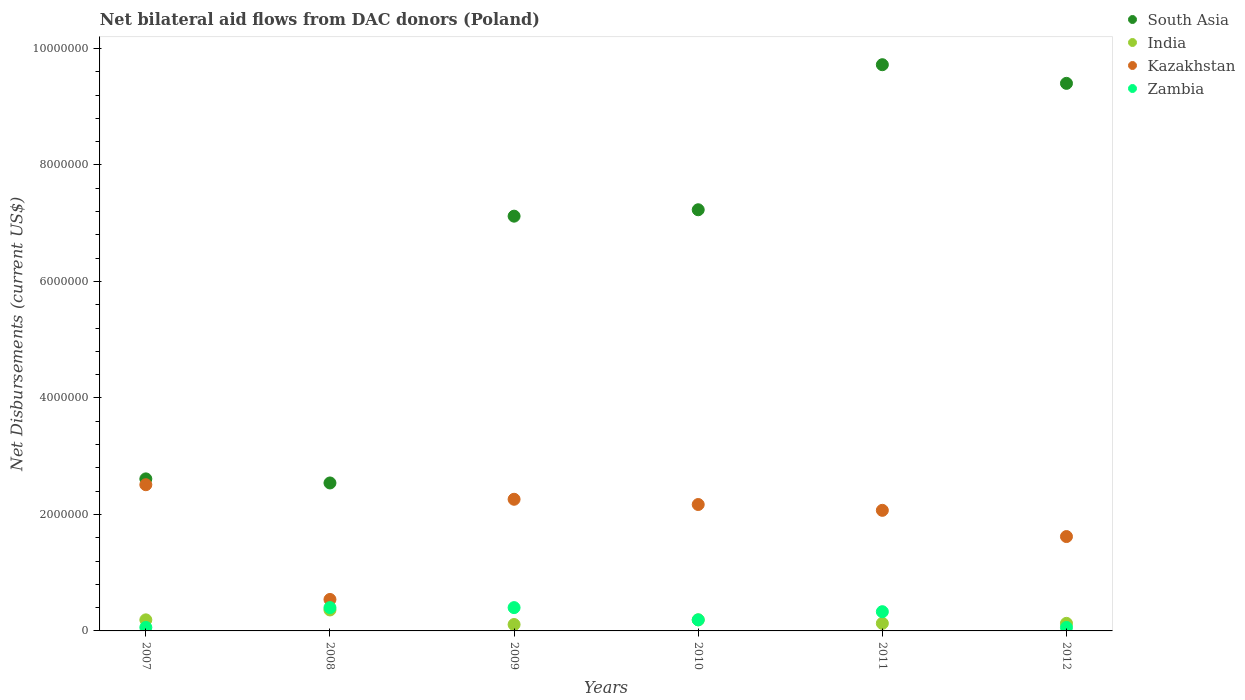How many different coloured dotlines are there?
Ensure brevity in your answer.  4. Is the number of dotlines equal to the number of legend labels?
Your answer should be compact. Yes. What is the net bilateral aid flows in Zambia in 2011?
Make the answer very short. 3.30e+05. Across all years, what is the maximum net bilateral aid flows in South Asia?
Provide a succinct answer. 9.72e+06. Across all years, what is the minimum net bilateral aid flows in Zambia?
Keep it short and to the point. 6.00e+04. In which year was the net bilateral aid flows in Zambia maximum?
Your response must be concise. 2008. In which year was the net bilateral aid flows in Zambia minimum?
Provide a succinct answer. 2007. What is the total net bilateral aid flows in South Asia in the graph?
Your response must be concise. 3.86e+07. What is the difference between the net bilateral aid flows in India in 2007 and that in 2012?
Provide a succinct answer. 6.00e+04. What is the difference between the net bilateral aid flows in Zambia in 2007 and the net bilateral aid flows in South Asia in 2010?
Ensure brevity in your answer.  -7.17e+06. What is the average net bilateral aid flows in South Asia per year?
Give a very brief answer. 6.44e+06. In the year 2012, what is the difference between the net bilateral aid flows in South Asia and net bilateral aid flows in Zambia?
Make the answer very short. 9.34e+06. In how many years, is the net bilateral aid flows in Zambia greater than 6400000 US$?
Keep it short and to the point. 0. What is the ratio of the net bilateral aid flows in India in 2007 to that in 2009?
Give a very brief answer. 1.73. Is the difference between the net bilateral aid flows in South Asia in 2007 and 2012 greater than the difference between the net bilateral aid flows in Zambia in 2007 and 2012?
Ensure brevity in your answer.  No. What is the difference between the highest and the lowest net bilateral aid flows in Zambia?
Your response must be concise. 3.40e+05. Is the sum of the net bilateral aid flows in Kazakhstan in 2010 and 2012 greater than the maximum net bilateral aid flows in India across all years?
Offer a very short reply. Yes. Is it the case that in every year, the sum of the net bilateral aid flows in Kazakhstan and net bilateral aid flows in India  is greater than the net bilateral aid flows in Zambia?
Ensure brevity in your answer.  Yes. Is the net bilateral aid flows in Zambia strictly greater than the net bilateral aid flows in South Asia over the years?
Ensure brevity in your answer.  No. Is the net bilateral aid flows in Kazakhstan strictly less than the net bilateral aid flows in South Asia over the years?
Provide a short and direct response. Yes. How many dotlines are there?
Offer a very short reply. 4. How many years are there in the graph?
Provide a succinct answer. 6. What is the difference between two consecutive major ticks on the Y-axis?
Provide a short and direct response. 2.00e+06. How many legend labels are there?
Your response must be concise. 4. How are the legend labels stacked?
Your response must be concise. Vertical. What is the title of the graph?
Provide a short and direct response. Net bilateral aid flows from DAC donors (Poland). Does "Syrian Arab Republic" appear as one of the legend labels in the graph?
Keep it short and to the point. No. What is the label or title of the X-axis?
Offer a terse response. Years. What is the label or title of the Y-axis?
Your answer should be compact. Net Disbursements (current US$). What is the Net Disbursements (current US$) of South Asia in 2007?
Ensure brevity in your answer.  2.61e+06. What is the Net Disbursements (current US$) in Kazakhstan in 2007?
Your response must be concise. 2.51e+06. What is the Net Disbursements (current US$) in Zambia in 2007?
Offer a terse response. 6.00e+04. What is the Net Disbursements (current US$) in South Asia in 2008?
Ensure brevity in your answer.  2.54e+06. What is the Net Disbursements (current US$) in India in 2008?
Offer a terse response. 3.60e+05. What is the Net Disbursements (current US$) of Kazakhstan in 2008?
Provide a short and direct response. 5.40e+05. What is the Net Disbursements (current US$) of South Asia in 2009?
Your response must be concise. 7.12e+06. What is the Net Disbursements (current US$) of India in 2009?
Your response must be concise. 1.10e+05. What is the Net Disbursements (current US$) of Kazakhstan in 2009?
Keep it short and to the point. 2.26e+06. What is the Net Disbursements (current US$) of South Asia in 2010?
Your answer should be compact. 7.23e+06. What is the Net Disbursements (current US$) of Kazakhstan in 2010?
Provide a short and direct response. 2.17e+06. What is the Net Disbursements (current US$) in Zambia in 2010?
Provide a short and direct response. 1.90e+05. What is the Net Disbursements (current US$) of South Asia in 2011?
Offer a very short reply. 9.72e+06. What is the Net Disbursements (current US$) in India in 2011?
Your answer should be compact. 1.30e+05. What is the Net Disbursements (current US$) in Kazakhstan in 2011?
Provide a short and direct response. 2.07e+06. What is the Net Disbursements (current US$) in Zambia in 2011?
Provide a short and direct response. 3.30e+05. What is the Net Disbursements (current US$) in South Asia in 2012?
Offer a very short reply. 9.40e+06. What is the Net Disbursements (current US$) of India in 2012?
Offer a terse response. 1.30e+05. What is the Net Disbursements (current US$) in Kazakhstan in 2012?
Keep it short and to the point. 1.62e+06. What is the Net Disbursements (current US$) of Zambia in 2012?
Offer a very short reply. 6.00e+04. Across all years, what is the maximum Net Disbursements (current US$) in South Asia?
Your response must be concise. 9.72e+06. Across all years, what is the maximum Net Disbursements (current US$) of Kazakhstan?
Provide a short and direct response. 2.51e+06. Across all years, what is the minimum Net Disbursements (current US$) of South Asia?
Ensure brevity in your answer.  2.54e+06. Across all years, what is the minimum Net Disbursements (current US$) in India?
Provide a short and direct response. 1.10e+05. Across all years, what is the minimum Net Disbursements (current US$) of Kazakhstan?
Give a very brief answer. 5.40e+05. Across all years, what is the minimum Net Disbursements (current US$) in Zambia?
Your response must be concise. 6.00e+04. What is the total Net Disbursements (current US$) of South Asia in the graph?
Your answer should be very brief. 3.86e+07. What is the total Net Disbursements (current US$) in India in the graph?
Your response must be concise. 1.11e+06. What is the total Net Disbursements (current US$) in Kazakhstan in the graph?
Offer a terse response. 1.12e+07. What is the total Net Disbursements (current US$) in Zambia in the graph?
Offer a very short reply. 1.44e+06. What is the difference between the Net Disbursements (current US$) in South Asia in 2007 and that in 2008?
Make the answer very short. 7.00e+04. What is the difference between the Net Disbursements (current US$) of India in 2007 and that in 2008?
Provide a short and direct response. -1.70e+05. What is the difference between the Net Disbursements (current US$) in Kazakhstan in 2007 and that in 2008?
Your answer should be very brief. 1.97e+06. What is the difference between the Net Disbursements (current US$) in South Asia in 2007 and that in 2009?
Offer a terse response. -4.51e+06. What is the difference between the Net Disbursements (current US$) of Kazakhstan in 2007 and that in 2009?
Ensure brevity in your answer.  2.50e+05. What is the difference between the Net Disbursements (current US$) of South Asia in 2007 and that in 2010?
Provide a short and direct response. -4.62e+06. What is the difference between the Net Disbursements (current US$) of India in 2007 and that in 2010?
Keep it short and to the point. 0. What is the difference between the Net Disbursements (current US$) in Kazakhstan in 2007 and that in 2010?
Your response must be concise. 3.40e+05. What is the difference between the Net Disbursements (current US$) in Zambia in 2007 and that in 2010?
Offer a very short reply. -1.30e+05. What is the difference between the Net Disbursements (current US$) of South Asia in 2007 and that in 2011?
Make the answer very short. -7.11e+06. What is the difference between the Net Disbursements (current US$) in India in 2007 and that in 2011?
Ensure brevity in your answer.  6.00e+04. What is the difference between the Net Disbursements (current US$) of Kazakhstan in 2007 and that in 2011?
Keep it short and to the point. 4.40e+05. What is the difference between the Net Disbursements (current US$) of South Asia in 2007 and that in 2012?
Offer a terse response. -6.79e+06. What is the difference between the Net Disbursements (current US$) in Kazakhstan in 2007 and that in 2012?
Keep it short and to the point. 8.90e+05. What is the difference between the Net Disbursements (current US$) of South Asia in 2008 and that in 2009?
Your answer should be compact. -4.58e+06. What is the difference between the Net Disbursements (current US$) of Kazakhstan in 2008 and that in 2009?
Offer a terse response. -1.72e+06. What is the difference between the Net Disbursements (current US$) of South Asia in 2008 and that in 2010?
Your answer should be very brief. -4.69e+06. What is the difference between the Net Disbursements (current US$) in India in 2008 and that in 2010?
Your answer should be very brief. 1.70e+05. What is the difference between the Net Disbursements (current US$) in Kazakhstan in 2008 and that in 2010?
Offer a terse response. -1.63e+06. What is the difference between the Net Disbursements (current US$) of South Asia in 2008 and that in 2011?
Your response must be concise. -7.18e+06. What is the difference between the Net Disbursements (current US$) of India in 2008 and that in 2011?
Your response must be concise. 2.30e+05. What is the difference between the Net Disbursements (current US$) in Kazakhstan in 2008 and that in 2011?
Ensure brevity in your answer.  -1.53e+06. What is the difference between the Net Disbursements (current US$) in Zambia in 2008 and that in 2011?
Provide a succinct answer. 7.00e+04. What is the difference between the Net Disbursements (current US$) in South Asia in 2008 and that in 2012?
Give a very brief answer. -6.86e+06. What is the difference between the Net Disbursements (current US$) of Kazakhstan in 2008 and that in 2012?
Provide a short and direct response. -1.08e+06. What is the difference between the Net Disbursements (current US$) of South Asia in 2009 and that in 2010?
Provide a succinct answer. -1.10e+05. What is the difference between the Net Disbursements (current US$) of India in 2009 and that in 2010?
Offer a very short reply. -8.00e+04. What is the difference between the Net Disbursements (current US$) of Kazakhstan in 2009 and that in 2010?
Your answer should be compact. 9.00e+04. What is the difference between the Net Disbursements (current US$) of South Asia in 2009 and that in 2011?
Offer a very short reply. -2.60e+06. What is the difference between the Net Disbursements (current US$) of India in 2009 and that in 2011?
Ensure brevity in your answer.  -2.00e+04. What is the difference between the Net Disbursements (current US$) of Zambia in 2009 and that in 2011?
Ensure brevity in your answer.  7.00e+04. What is the difference between the Net Disbursements (current US$) in South Asia in 2009 and that in 2012?
Provide a short and direct response. -2.28e+06. What is the difference between the Net Disbursements (current US$) of Kazakhstan in 2009 and that in 2012?
Offer a terse response. 6.40e+05. What is the difference between the Net Disbursements (current US$) of South Asia in 2010 and that in 2011?
Your response must be concise. -2.49e+06. What is the difference between the Net Disbursements (current US$) in India in 2010 and that in 2011?
Ensure brevity in your answer.  6.00e+04. What is the difference between the Net Disbursements (current US$) in Zambia in 2010 and that in 2011?
Your answer should be very brief. -1.40e+05. What is the difference between the Net Disbursements (current US$) in South Asia in 2010 and that in 2012?
Make the answer very short. -2.17e+06. What is the difference between the Net Disbursements (current US$) of Kazakhstan in 2010 and that in 2012?
Offer a terse response. 5.50e+05. What is the difference between the Net Disbursements (current US$) in South Asia in 2011 and that in 2012?
Make the answer very short. 3.20e+05. What is the difference between the Net Disbursements (current US$) in Zambia in 2011 and that in 2012?
Keep it short and to the point. 2.70e+05. What is the difference between the Net Disbursements (current US$) of South Asia in 2007 and the Net Disbursements (current US$) of India in 2008?
Offer a very short reply. 2.25e+06. What is the difference between the Net Disbursements (current US$) in South Asia in 2007 and the Net Disbursements (current US$) in Kazakhstan in 2008?
Keep it short and to the point. 2.07e+06. What is the difference between the Net Disbursements (current US$) of South Asia in 2007 and the Net Disbursements (current US$) of Zambia in 2008?
Offer a terse response. 2.21e+06. What is the difference between the Net Disbursements (current US$) in India in 2007 and the Net Disbursements (current US$) in Kazakhstan in 2008?
Give a very brief answer. -3.50e+05. What is the difference between the Net Disbursements (current US$) in India in 2007 and the Net Disbursements (current US$) in Zambia in 2008?
Provide a short and direct response. -2.10e+05. What is the difference between the Net Disbursements (current US$) of Kazakhstan in 2007 and the Net Disbursements (current US$) of Zambia in 2008?
Offer a terse response. 2.11e+06. What is the difference between the Net Disbursements (current US$) in South Asia in 2007 and the Net Disbursements (current US$) in India in 2009?
Offer a very short reply. 2.50e+06. What is the difference between the Net Disbursements (current US$) of South Asia in 2007 and the Net Disbursements (current US$) of Zambia in 2009?
Provide a short and direct response. 2.21e+06. What is the difference between the Net Disbursements (current US$) of India in 2007 and the Net Disbursements (current US$) of Kazakhstan in 2009?
Give a very brief answer. -2.07e+06. What is the difference between the Net Disbursements (current US$) of India in 2007 and the Net Disbursements (current US$) of Zambia in 2009?
Give a very brief answer. -2.10e+05. What is the difference between the Net Disbursements (current US$) of Kazakhstan in 2007 and the Net Disbursements (current US$) of Zambia in 2009?
Your answer should be compact. 2.11e+06. What is the difference between the Net Disbursements (current US$) in South Asia in 2007 and the Net Disbursements (current US$) in India in 2010?
Make the answer very short. 2.42e+06. What is the difference between the Net Disbursements (current US$) of South Asia in 2007 and the Net Disbursements (current US$) of Kazakhstan in 2010?
Your response must be concise. 4.40e+05. What is the difference between the Net Disbursements (current US$) in South Asia in 2007 and the Net Disbursements (current US$) in Zambia in 2010?
Provide a short and direct response. 2.42e+06. What is the difference between the Net Disbursements (current US$) of India in 2007 and the Net Disbursements (current US$) of Kazakhstan in 2010?
Provide a short and direct response. -1.98e+06. What is the difference between the Net Disbursements (current US$) of Kazakhstan in 2007 and the Net Disbursements (current US$) of Zambia in 2010?
Your response must be concise. 2.32e+06. What is the difference between the Net Disbursements (current US$) of South Asia in 2007 and the Net Disbursements (current US$) of India in 2011?
Provide a short and direct response. 2.48e+06. What is the difference between the Net Disbursements (current US$) in South Asia in 2007 and the Net Disbursements (current US$) in Kazakhstan in 2011?
Your answer should be very brief. 5.40e+05. What is the difference between the Net Disbursements (current US$) in South Asia in 2007 and the Net Disbursements (current US$) in Zambia in 2011?
Your answer should be compact. 2.28e+06. What is the difference between the Net Disbursements (current US$) of India in 2007 and the Net Disbursements (current US$) of Kazakhstan in 2011?
Your response must be concise. -1.88e+06. What is the difference between the Net Disbursements (current US$) in Kazakhstan in 2007 and the Net Disbursements (current US$) in Zambia in 2011?
Provide a short and direct response. 2.18e+06. What is the difference between the Net Disbursements (current US$) in South Asia in 2007 and the Net Disbursements (current US$) in India in 2012?
Your answer should be very brief. 2.48e+06. What is the difference between the Net Disbursements (current US$) in South Asia in 2007 and the Net Disbursements (current US$) in Kazakhstan in 2012?
Provide a short and direct response. 9.90e+05. What is the difference between the Net Disbursements (current US$) in South Asia in 2007 and the Net Disbursements (current US$) in Zambia in 2012?
Offer a very short reply. 2.55e+06. What is the difference between the Net Disbursements (current US$) of India in 2007 and the Net Disbursements (current US$) of Kazakhstan in 2012?
Provide a short and direct response. -1.43e+06. What is the difference between the Net Disbursements (current US$) of Kazakhstan in 2007 and the Net Disbursements (current US$) of Zambia in 2012?
Provide a succinct answer. 2.45e+06. What is the difference between the Net Disbursements (current US$) in South Asia in 2008 and the Net Disbursements (current US$) in India in 2009?
Provide a short and direct response. 2.43e+06. What is the difference between the Net Disbursements (current US$) of South Asia in 2008 and the Net Disbursements (current US$) of Kazakhstan in 2009?
Ensure brevity in your answer.  2.80e+05. What is the difference between the Net Disbursements (current US$) in South Asia in 2008 and the Net Disbursements (current US$) in Zambia in 2009?
Your answer should be very brief. 2.14e+06. What is the difference between the Net Disbursements (current US$) in India in 2008 and the Net Disbursements (current US$) in Kazakhstan in 2009?
Your response must be concise. -1.90e+06. What is the difference between the Net Disbursements (current US$) of South Asia in 2008 and the Net Disbursements (current US$) of India in 2010?
Make the answer very short. 2.35e+06. What is the difference between the Net Disbursements (current US$) of South Asia in 2008 and the Net Disbursements (current US$) of Zambia in 2010?
Your response must be concise. 2.35e+06. What is the difference between the Net Disbursements (current US$) in India in 2008 and the Net Disbursements (current US$) in Kazakhstan in 2010?
Ensure brevity in your answer.  -1.81e+06. What is the difference between the Net Disbursements (current US$) in Kazakhstan in 2008 and the Net Disbursements (current US$) in Zambia in 2010?
Offer a terse response. 3.50e+05. What is the difference between the Net Disbursements (current US$) of South Asia in 2008 and the Net Disbursements (current US$) of India in 2011?
Offer a very short reply. 2.41e+06. What is the difference between the Net Disbursements (current US$) of South Asia in 2008 and the Net Disbursements (current US$) of Kazakhstan in 2011?
Your response must be concise. 4.70e+05. What is the difference between the Net Disbursements (current US$) in South Asia in 2008 and the Net Disbursements (current US$) in Zambia in 2011?
Your response must be concise. 2.21e+06. What is the difference between the Net Disbursements (current US$) of India in 2008 and the Net Disbursements (current US$) of Kazakhstan in 2011?
Keep it short and to the point. -1.71e+06. What is the difference between the Net Disbursements (current US$) in India in 2008 and the Net Disbursements (current US$) in Zambia in 2011?
Keep it short and to the point. 3.00e+04. What is the difference between the Net Disbursements (current US$) in South Asia in 2008 and the Net Disbursements (current US$) in India in 2012?
Your response must be concise. 2.41e+06. What is the difference between the Net Disbursements (current US$) of South Asia in 2008 and the Net Disbursements (current US$) of Kazakhstan in 2012?
Provide a succinct answer. 9.20e+05. What is the difference between the Net Disbursements (current US$) of South Asia in 2008 and the Net Disbursements (current US$) of Zambia in 2012?
Ensure brevity in your answer.  2.48e+06. What is the difference between the Net Disbursements (current US$) in India in 2008 and the Net Disbursements (current US$) in Kazakhstan in 2012?
Provide a short and direct response. -1.26e+06. What is the difference between the Net Disbursements (current US$) in India in 2008 and the Net Disbursements (current US$) in Zambia in 2012?
Provide a succinct answer. 3.00e+05. What is the difference between the Net Disbursements (current US$) of Kazakhstan in 2008 and the Net Disbursements (current US$) of Zambia in 2012?
Provide a short and direct response. 4.80e+05. What is the difference between the Net Disbursements (current US$) of South Asia in 2009 and the Net Disbursements (current US$) of India in 2010?
Offer a terse response. 6.93e+06. What is the difference between the Net Disbursements (current US$) of South Asia in 2009 and the Net Disbursements (current US$) of Kazakhstan in 2010?
Give a very brief answer. 4.95e+06. What is the difference between the Net Disbursements (current US$) in South Asia in 2009 and the Net Disbursements (current US$) in Zambia in 2010?
Offer a very short reply. 6.93e+06. What is the difference between the Net Disbursements (current US$) in India in 2009 and the Net Disbursements (current US$) in Kazakhstan in 2010?
Provide a succinct answer. -2.06e+06. What is the difference between the Net Disbursements (current US$) in India in 2009 and the Net Disbursements (current US$) in Zambia in 2010?
Ensure brevity in your answer.  -8.00e+04. What is the difference between the Net Disbursements (current US$) of Kazakhstan in 2009 and the Net Disbursements (current US$) of Zambia in 2010?
Provide a short and direct response. 2.07e+06. What is the difference between the Net Disbursements (current US$) of South Asia in 2009 and the Net Disbursements (current US$) of India in 2011?
Your response must be concise. 6.99e+06. What is the difference between the Net Disbursements (current US$) of South Asia in 2009 and the Net Disbursements (current US$) of Kazakhstan in 2011?
Keep it short and to the point. 5.05e+06. What is the difference between the Net Disbursements (current US$) in South Asia in 2009 and the Net Disbursements (current US$) in Zambia in 2011?
Keep it short and to the point. 6.79e+06. What is the difference between the Net Disbursements (current US$) of India in 2009 and the Net Disbursements (current US$) of Kazakhstan in 2011?
Offer a very short reply. -1.96e+06. What is the difference between the Net Disbursements (current US$) in Kazakhstan in 2009 and the Net Disbursements (current US$) in Zambia in 2011?
Your answer should be compact. 1.93e+06. What is the difference between the Net Disbursements (current US$) of South Asia in 2009 and the Net Disbursements (current US$) of India in 2012?
Provide a succinct answer. 6.99e+06. What is the difference between the Net Disbursements (current US$) in South Asia in 2009 and the Net Disbursements (current US$) in Kazakhstan in 2012?
Keep it short and to the point. 5.50e+06. What is the difference between the Net Disbursements (current US$) in South Asia in 2009 and the Net Disbursements (current US$) in Zambia in 2012?
Offer a terse response. 7.06e+06. What is the difference between the Net Disbursements (current US$) of India in 2009 and the Net Disbursements (current US$) of Kazakhstan in 2012?
Give a very brief answer. -1.51e+06. What is the difference between the Net Disbursements (current US$) of Kazakhstan in 2009 and the Net Disbursements (current US$) of Zambia in 2012?
Provide a short and direct response. 2.20e+06. What is the difference between the Net Disbursements (current US$) of South Asia in 2010 and the Net Disbursements (current US$) of India in 2011?
Give a very brief answer. 7.10e+06. What is the difference between the Net Disbursements (current US$) in South Asia in 2010 and the Net Disbursements (current US$) in Kazakhstan in 2011?
Provide a short and direct response. 5.16e+06. What is the difference between the Net Disbursements (current US$) of South Asia in 2010 and the Net Disbursements (current US$) of Zambia in 2011?
Make the answer very short. 6.90e+06. What is the difference between the Net Disbursements (current US$) of India in 2010 and the Net Disbursements (current US$) of Kazakhstan in 2011?
Offer a terse response. -1.88e+06. What is the difference between the Net Disbursements (current US$) of Kazakhstan in 2010 and the Net Disbursements (current US$) of Zambia in 2011?
Your answer should be compact. 1.84e+06. What is the difference between the Net Disbursements (current US$) in South Asia in 2010 and the Net Disbursements (current US$) in India in 2012?
Give a very brief answer. 7.10e+06. What is the difference between the Net Disbursements (current US$) of South Asia in 2010 and the Net Disbursements (current US$) of Kazakhstan in 2012?
Ensure brevity in your answer.  5.61e+06. What is the difference between the Net Disbursements (current US$) in South Asia in 2010 and the Net Disbursements (current US$) in Zambia in 2012?
Offer a very short reply. 7.17e+06. What is the difference between the Net Disbursements (current US$) of India in 2010 and the Net Disbursements (current US$) of Kazakhstan in 2012?
Make the answer very short. -1.43e+06. What is the difference between the Net Disbursements (current US$) in Kazakhstan in 2010 and the Net Disbursements (current US$) in Zambia in 2012?
Provide a short and direct response. 2.11e+06. What is the difference between the Net Disbursements (current US$) in South Asia in 2011 and the Net Disbursements (current US$) in India in 2012?
Your answer should be compact. 9.59e+06. What is the difference between the Net Disbursements (current US$) of South Asia in 2011 and the Net Disbursements (current US$) of Kazakhstan in 2012?
Make the answer very short. 8.10e+06. What is the difference between the Net Disbursements (current US$) of South Asia in 2011 and the Net Disbursements (current US$) of Zambia in 2012?
Provide a short and direct response. 9.66e+06. What is the difference between the Net Disbursements (current US$) of India in 2011 and the Net Disbursements (current US$) of Kazakhstan in 2012?
Offer a very short reply. -1.49e+06. What is the difference between the Net Disbursements (current US$) of India in 2011 and the Net Disbursements (current US$) of Zambia in 2012?
Keep it short and to the point. 7.00e+04. What is the difference between the Net Disbursements (current US$) in Kazakhstan in 2011 and the Net Disbursements (current US$) in Zambia in 2012?
Make the answer very short. 2.01e+06. What is the average Net Disbursements (current US$) in South Asia per year?
Make the answer very short. 6.44e+06. What is the average Net Disbursements (current US$) of India per year?
Give a very brief answer. 1.85e+05. What is the average Net Disbursements (current US$) of Kazakhstan per year?
Give a very brief answer. 1.86e+06. In the year 2007, what is the difference between the Net Disbursements (current US$) of South Asia and Net Disbursements (current US$) of India?
Provide a succinct answer. 2.42e+06. In the year 2007, what is the difference between the Net Disbursements (current US$) of South Asia and Net Disbursements (current US$) of Zambia?
Provide a succinct answer. 2.55e+06. In the year 2007, what is the difference between the Net Disbursements (current US$) in India and Net Disbursements (current US$) in Kazakhstan?
Provide a short and direct response. -2.32e+06. In the year 2007, what is the difference between the Net Disbursements (current US$) in India and Net Disbursements (current US$) in Zambia?
Your answer should be very brief. 1.30e+05. In the year 2007, what is the difference between the Net Disbursements (current US$) of Kazakhstan and Net Disbursements (current US$) of Zambia?
Ensure brevity in your answer.  2.45e+06. In the year 2008, what is the difference between the Net Disbursements (current US$) in South Asia and Net Disbursements (current US$) in India?
Your answer should be very brief. 2.18e+06. In the year 2008, what is the difference between the Net Disbursements (current US$) in South Asia and Net Disbursements (current US$) in Zambia?
Offer a terse response. 2.14e+06. In the year 2008, what is the difference between the Net Disbursements (current US$) in India and Net Disbursements (current US$) in Kazakhstan?
Offer a very short reply. -1.80e+05. In the year 2008, what is the difference between the Net Disbursements (current US$) in India and Net Disbursements (current US$) in Zambia?
Offer a terse response. -4.00e+04. In the year 2008, what is the difference between the Net Disbursements (current US$) in Kazakhstan and Net Disbursements (current US$) in Zambia?
Provide a short and direct response. 1.40e+05. In the year 2009, what is the difference between the Net Disbursements (current US$) of South Asia and Net Disbursements (current US$) of India?
Offer a very short reply. 7.01e+06. In the year 2009, what is the difference between the Net Disbursements (current US$) of South Asia and Net Disbursements (current US$) of Kazakhstan?
Offer a terse response. 4.86e+06. In the year 2009, what is the difference between the Net Disbursements (current US$) of South Asia and Net Disbursements (current US$) of Zambia?
Your answer should be compact. 6.72e+06. In the year 2009, what is the difference between the Net Disbursements (current US$) in India and Net Disbursements (current US$) in Kazakhstan?
Offer a terse response. -2.15e+06. In the year 2009, what is the difference between the Net Disbursements (current US$) of Kazakhstan and Net Disbursements (current US$) of Zambia?
Your response must be concise. 1.86e+06. In the year 2010, what is the difference between the Net Disbursements (current US$) of South Asia and Net Disbursements (current US$) of India?
Your answer should be compact. 7.04e+06. In the year 2010, what is the difference between the Net Disbursements (current US$) of South Asia and Net Disbursements (current US$) of Kazakhstan?
Give a very brief answer. 5.06e+06. In the year 2010, what is the difference between the Net Disbursements (current US$) in South Asia and Net Disbursements (current US$) in Zambia?
Your answer should be compact. 7.04e+06. In the year 2010, what is the difference between the Net Disbursements (current US$) of India and Net Disbursements (current US$) of Kazakhstan?
Your answer should be very brief. -1.98e+06. In the year 2010, what is the difference between the Net Disbursements (current US$) of India and Net Disbursements (current US$) of Zambia?
Offer a very short reply. 0. In the year 2010, what is the difference between the Net Disbursements (current US$) of Kazakhstan and Net Disbursements (current US$) of Zambia?
Give a very brief answer. 1.98e+06. In the year 2011, what is the difference between the Net Disbursements (current US$) in South Asia and Net Disbursements (current US$) in India?
Your answer should be very brief. 9.59e+06. In the year 2011, what is the difference between the Net Disbursements (current US$) in South Asia and Net Disbursements (current US$) in Kazakhstan?
Ensure brevity in your answer.  7.65e+06. In the year 2011, what is the difference between the Net Disbursements (current US$) of South Asia and Net Disbursements (current US$) of Zambia?
Your answer should be very brief. 9.39e+06. In the year 2011, what is the difference between the Net Disbursements (current US$) of India and Net Disbursements (current US$) of Kazakhstan?
Give a very brief answer. -1.94e+06. In the year 2011, what is the difference between the Net Disbursements (current US$) in Kazakhstan and Net Disbursements (current US$) in Zambia?
Ensure brevity in your answer.  1.74e+06. In the year 2012, what is the difference between the Net Disbursements (current US$) of South Asia and Net Disbursements (current US$) of India?
Keep it short and to the point. 9.27e+06. In the year 2012, what is the difference between the Net Disbursements (current US$) in South Asia and Net Disbursements (current US$) in Kazakhstan?
Offer a terse response. 7.78e+06. In the year 2012, what is the difference between the Net Disbursements (current US$) of South Asia and Net Disbursements (current US$) of Zambia?
Ensure brevity in your answer.  9.34e+06. In the year 2012, what is the difference between the Net Disbursements (current US$) in India and Net Disbursements (current US$) in Kazakhstan?
Make the answer very short. -1.49e+06. In the year 2012, what is the difference between the Net Disbursements (current US$) of Kazakhstan and Net Disbursements (current US$) of Zambia?
Your answer should be compact. 1.56e+06. What is the ratio of the Net Disbursements (current US$) of South Asia in 2007 to that in 2008?
Give a very brief answer. 1.03. What is the ratio of the Net Disbursements (current US$) in India in 2007 to that in 2008?
Provide a succinct answer. 0.53. What is the ratio of the Net Disbursements (current US$) of Kazakhstan in 2007 to that in 2008?
Offer a terse response. 4.65. What is the ratio of the Net Disbursements (current US$) of Zambia in 2007 to that in 2008?
Provide a short and direct response. 0.15. What is the ratio of the Net Disbursements (current US$) in South Asia in 2007 to that in 2009?
Make the answer very short. 0.37. What is the ratio of the Net Disbursements (current US$) in India in 2007 to that in 2009?
Provide a succinct answer. 1.73. What is the ratio of the Net Disbursements (current US$) in Kazakhstan in 2007 to that in 2009?
Keep it short and to the point. 1.11. What is the ratio of the Net Disbursements (current US$) of Zambia in 2007 to that in 2009?
Keep it short and to the point. 0.15. What is the ratio of the Net Disbursements (current US$) in South Asia in 2007 to that in 2010?
Provide a succinct answer. 0.36. What is the ratio of the Net Disbursements (current US$) of India in 2007 to that in 2010?
Make the answer very short. 1. What is the ratio of the Net Disbursements (current US$) of Kazakhstan in 2007 to that in 2010?
Make the answer very short. 1.16. What is the ratio of the Net Disbursements (current US$) in Zambia in 2007 to that in 2010?
Your response must be concise. 0.32. What is the ratio of the Net Disbursements (current US$) in South Asia in 2007 to that in 2011?
Keep it short and to the point. 0.27. What is the ratio of the Net Disbursements (current US$) in India in 2007 to that in 2011?
Your answer should be very brief. 1.46. What is the ratio of the Net Disbursements (current US$) in Kazakhstan in 2007 to that in 2011?
Your answer should be compact. 1.21. What is the ratio of the Net Disbursements (current US$) of Zambia in 2007 to that in 2011?
Provide a short and direct response. 0.18. What is the ratio of the Net Disbursements (current US$) in South Asia in 2007 to that in 2012?
Provide a short and direct response. 0.28. What is the ratio of the Net Disbursements (current US$) in India in 2007 to that in 2012?
Your answer should be very brief. 1.46. What is the ratio of the Net Disbursements (current US$) in Kazakhstan in 2007 to that in 2012?
Your answer should be compact. 1.55. What is the ratio of the Net Disbursements (current US$) of South Asia in 2008 to that in 2009?
Your answer should be very brief. 0.36. What is the ratio of the Net Disbursements (current US$) of India in 2008 to that in 2009?
Provide a short and direct response. 3.27. What is the ratio of the Net Disbursements (current US$) in Kazakhstan in 2008 to that in 2009?
Make the answer very short. 0.24. What is the ratio of the Net Disbursements (current US$) in Zambia in 2008 to that in 2009?
Ensure brevity in your answer.  1. What is the ratio of the Net Disbursements (current US$) of South Asia in 2008 to that in 2010?
Your answer should be very brief. 0.35. What is the ratio of the Net Disbursements (current US$) in India in 2008 to that in 2010?
Make the answer very short. 1.89. What is the ratio of the Net Disbursements (current US$) of Kazakhstan in 2008 to that in 2010?
Your answer should be compact. 0.25. What is the ratio of the Net Disbursements (current US$) of Zambia in 2008 to that in 2010?
Your response must be concise. 2.11. What is the ratio of the Net Disbursements (current US$) of South Asia in 2008 to that in 2011?
Keep it short and to the point. 0.26. What is the ratio of the Net Disbursements (current US$) of India in 2008 to that in 2011?
Ensure brevity in your answer.  2.77. What is the ratio of the Net Disbursements (current US$) of Kazakhstan in 2008 to that in 2011?
Offer a terse response. 0.26. What is the ratio of the Net Disbursements (current US$) in Zambia in 2008 to that in 2011?
Offer a very short reply. 1.21. What is the ratio of the Net Disbursements (current US$) in South Asia in 2008 to that in 2012?
Give a very brief answer. 0.27. What is the ratio of the Net Disbursements (current US$) of India in 2008 to that in 2012?
Keep it short and to the point. 2.77. What is the ratio of the Net Disbursements (current US$) of Kazakhstan in 2008 to that in 2012?
Your answer should be very brief. 0.33. What is the ratio of the Net Disbursements (current US$) in Zambia in 2008 to that in 2012?
Your answer should be very brief. 6.67. What is the ratio of the Net Disbursements (current US$) of India in 2009 to that in 2010?
Your response must be concise. 0.58. What is the ratio of the Net Disbursements (current US$) of Kazakhstan in 2009 to that in 2010?
Keep it short and to the point. 1.04. What is the ratio of the Net Disbursements (current US$) of Zambia in 2009 to that in 2010?
Ensure brevity in your answer.  2.11. What is the ratio of the Net Disbursements (current US$) of South Asia in 2009 to that in 2011?
Your answer should be compact. 0.73. What is the ratio of the Net Disbursements (current US$) in India in 2009 to that in 2011?
Your answer should be very brief. 0.85. What is the ratio of the Net Disbursements (current US$) in Kazakhstan in 2009 to that in 2011?
Provide a succinct answer. 1.09. What is the ratio of the Net Disbursements (current US$) of Zambia in 2009 to that in 2011?
Keep it short and to the point. 1.21. What is the ratio of the Net Disbursements (current US$) in South Asia in 2009 to that in 2012?
Your response must be concise. 0.76. What is the ratio of the Net Disbursements (current US$) in India in 2009 to that in 2012?
Ensure brevity in your answer.  0.85. What is the ratio of the Net Disbursements (current US$) of Kazakhstan in 2009 to that in 2012?
Provide a short and direct response. 1.4. What is the ratio of the Net Disbursements (current US$) in South Asia in 2010 to that in 2011?
Your answer should be compact. 0.74. What is the ratio of the Net Disbursements (current US$) of India in 2010 to that in 2011?
Provide a short and direct response. 1.46. What is the ratio of the Net Disbursements (current US$) in Kazakhstan in 2010 to that in 2011?
Your answer should be compact. 1.05. What is the ratio of the Net Disbursements (current US$) in Zambia in 2010 to that in 2011?
Keep it short and to the point. 0.58. What is the ratio of the Net Disbursements (current US$) in South Asia in 2010 to that in 2012?
Offer a very short reply. 0.77. What is the ratio of the Net Disbursements (current US$) in India in 2010 to that in 2012?
Keep it short and to the point. 1.46. What is the ratio of the Net Disbursements (current US$) in Kazakhstan in 2010 to that in 2012?
Give a very brief answer. 1.34. What is the ratio of the Net Disbursements (current US$) of Zambia in 2010 to that in 2012?
Ensure brevity in your answer.  3.17. What is the ratio of the Net Disbursements (current US$) of South Asia in 2011 to that in 2012?
Keep it short and to the point. 1.03. What is the ratio of the Net Disbursements (current US$) of Kazakhstan in 2011 to that in 2012?
Keep it short and to the point. 1.28. What is the difference between the highest and the second highest Net Disbursements (current US$) of South Asia?
Your response must be concise. 3.20e+05. What is the difference between the highest and the second highest Net Disbursements (current US$) of Kazakhstan?
Provide a succinct answer. 2.50e+05. What is the difference between the highest and the lowest Net Disbursements (current US$) of South Asia?
Make the answer very short. 7.18e+06. What is the difference between the highest and the lowest Net Disbursements (current US$) of Kazakhstan?
Make the answer very short. 1.97e+06. 